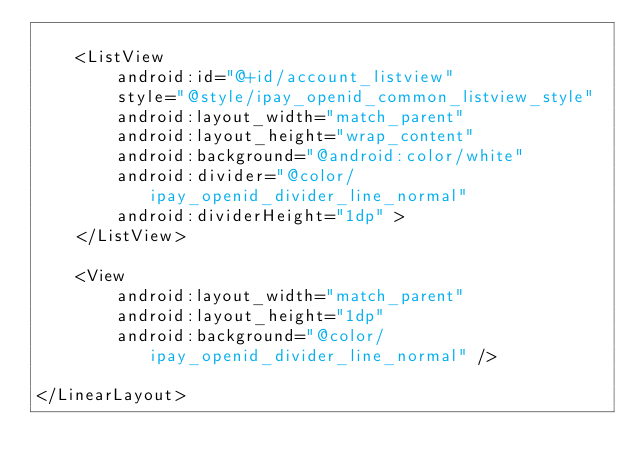<code> <loc_0><loc_0><loc_500><loc_500><_XML_>
    <ListView
        android:id="@+id/account_listview"
        style="@style/ipay_openid_common_listview_style"
        android:layout_width="match_parent"
        android:layout_height="wrap_content"
        android:background="@android:color/white"
        android:divider="@color/ipay_openid_divider_line_normal"
        android:dividerHeight="1dp" >
    </ListView>

    <View
        android:layout_width="match_parent"
        android:layout_height="1dp"
        android:background="@color/ipay_openid_divider_line_normal" />

</LinearLayout></code> 